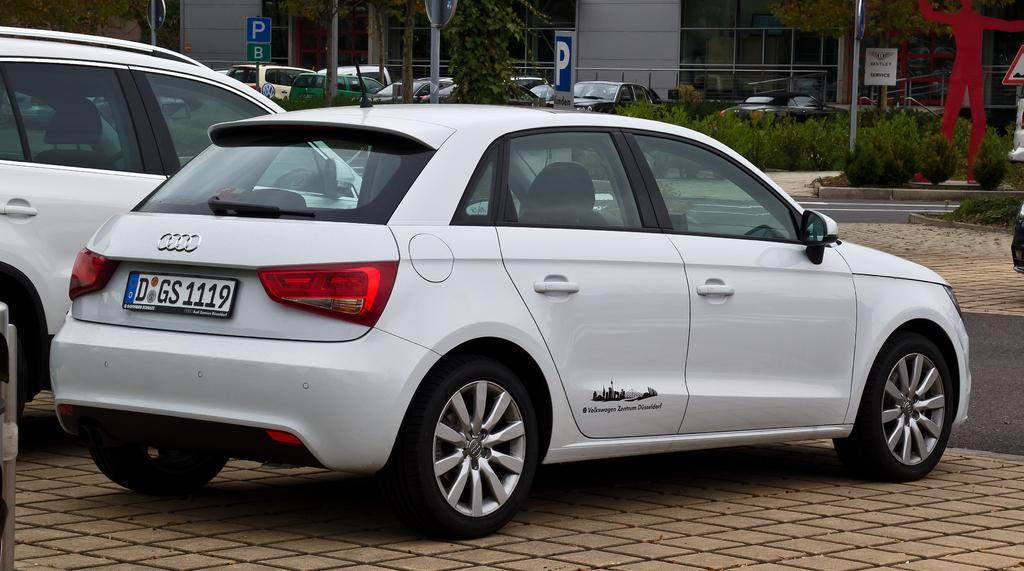How would you summarize this image in a sentence or two? In this image we can see vehicles, boards, poles, plants, walls, glass windows and things. 